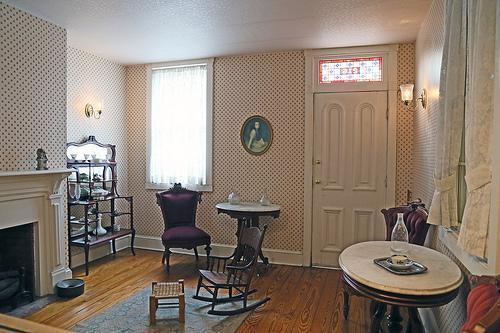How many purple chairs are there?
Give a very brief answer. 1. 